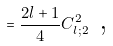<formula> <loc_0><loc_0><loc_500><loc_500>= \frac { 2 l + 1 } { 4 } C _ { l ; 2 } ^ { 2 } \text { ,}</formula> 